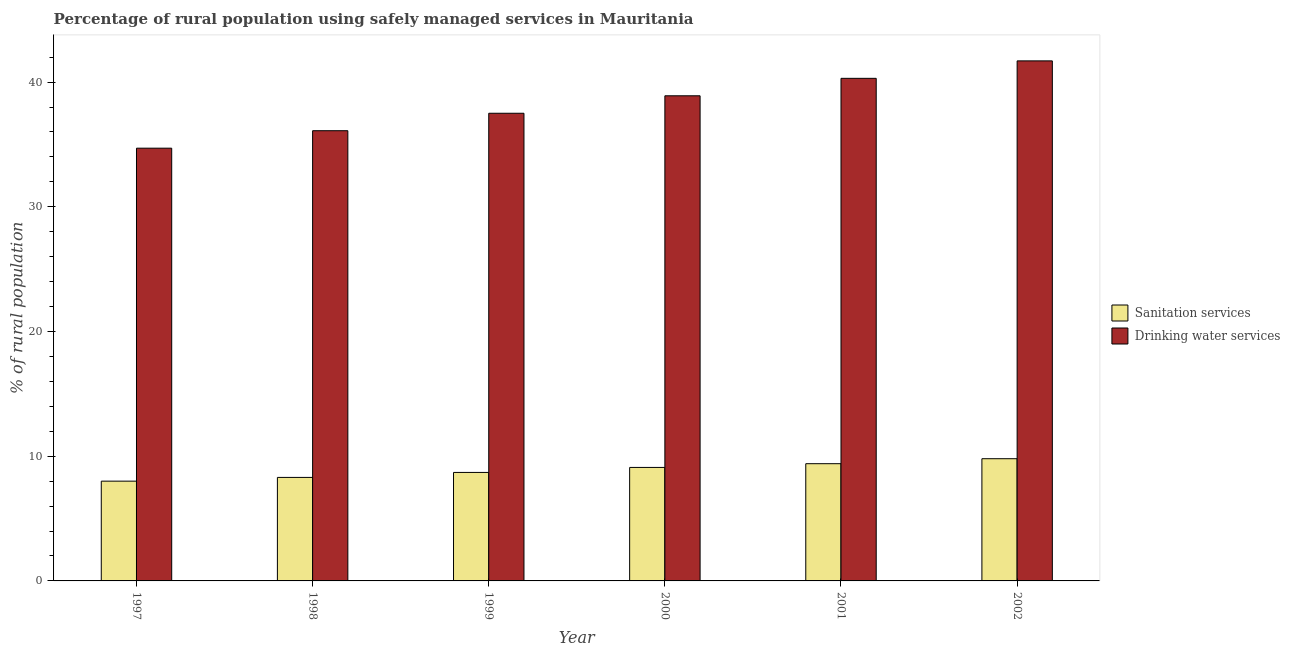How many different coloured bars are there?
Provide a short and direct response. 2. Are the number of bars per tick equal to the number of legend labels?
Give a very brief answer. Yes. What is the label of the 5th group of bars from the left?
Make the answer very short. 2001. Across all years, what is the maximum percentage of rural population who used drinking water services?
Provide a short and direct response. 41.7. Across all years, what is the minimum percentage of rural population who used sanitation services?
Offer a terse response. 8. In which year was the percentage of rural population who used sanitation services minimum?
Your answer should be compact. 1997. What is the total percentage of rural population who used drinking water services in the graph?
Your answer should be very brief. 229.2. What is the difference between the percentage of rural population who used sanitation services in 1998 and that in 1999?
Make the answer very short. -0.4. What is the difference between the percentage of rural population who used sanitation services in 2000 and the percentage of rural population who used drinking water services in 1999?
Offer a terse response. 0.4. What is the average percentage of rural population who used drinking water services per year?
Your answer should be compact. 38.2. In how many years, is the percentage of rural population who used sanitation services greater than 12 %?
Make the answer very short. 0. What is the ratio of the percentage of rural population who used drinking water services in 1998 to that in 2002?
Provide a short and direct response. 0.87. Is the percentage of rural population who used drinking water services in 1997 less than that in 1998?
Provide a short and direct response. Yes. What is the difference between the highest and the second highest percentage of rural population who used drinking water services?
Offer a terse response. 1.4. What is the difference between the highest and the lowest percentage of rural population who used drinking water services?
Ensure brevity in your answer.  7. What does the 2nd bar from the left in 1998 represents?
Your response must be concise. Drinking water services. What does the 1st bar from the right in 1999 represents?
Your response must be concise. Drinking water services. How many bars are there?
Ensure brevity in your answer.  12. Are all the bars in the graph horizontal?
Offer a very short reply. No. What is the difference between two consecutive major ticks on the Y-axis?
Ensure brevity in your answer.  10. Does the graph contain any zero values?
Give a very brief answer. No. What is the title of the graph?
Provide a short and direct response. Percentage of rural population using safely managed services in Mauritania. What is the label or title of the X-axis?
Ensure brevity in your answer.  Year. What is the label or title of the Y-axis?
Ensure brevity in your answer.  % of rural population. What is the % of rural population of Sanitation services in 1997?
Ensure brevity in your answer.  8. What is the % of rural population of Drinking water services in 1997?
Offer a very short reply. 34.7. What is the % of rural population of Drinking water services in 1998?
Keep it short and to the point. 36.1. What is the % of rural population in Sanitation services in 1999?
Provide a succinct answer. 8.7. What is the % of rural population in Drinking water services in 1999?
Provide a short and direct response. 37.5. What is the % of rural population in Sanitation services in 2000?
Your answer should be compact. 9.1. What is the % of rural population of Drinking water services in 2000?
Your answer should be very brief. 38.9. What is the % of rural population in Drinking water services in 2001?
Your answer should be compact. 40.3. What is the % of rural population of Sanitation services in 2002?
Your answer should be compact. 9.8. What is the % of rural population of Drinking water services in 2002?
Offer a terse response. 41.7. Across all years, what is the maximum % of rural population in Sanitation services?
Your answer should be compact. 9.8. Across all years, what is the maximum % of rural population in Drinking water services?
Offer a terse response. 41.7. Across all years, what is the minimum % of rural population in Drinking water services?
Provide a succinct answer. 34.7. What is the total % of rural population in Sanitation services in the graph?
Ensure brevity in your answer.  53.3. What is the total % of rural population of Drinking water services in the graph?
Your answer should be compact. 229.2. What is the difference between the % of rural population of Drinking water services in 1997 and that in 1998?
Keep it short and to the point. -1.4. What is the difference between the % of rural population in Sanitation services in 1997 and that in 1999?
Your response must be concise. -0.7. What is the difference between the % of rural population in Drinking water services in 1997 and that in 1999?
Offer a very short reply. -2.8. What is the difference between the % of rural population in Sanitation services in 1997 and that in 2001?
Provide a short and direct response. -1.4. What is the difference between the % of rural population of Sanitation services in 1997 and that in 2002?
Offer a very short reply. -1.8. What is the difference between the % of rural population in Drinking water services in 1997 and that in 2002?
Your response must be concise. -7. What is the difference between the % of rural population of Drinking water services in 1998 and that in 1999?
Provide a succinct answer. -1.4. What is the difference between the % of rural population of Sanitation services in 1998 and that in 2001?
Make the answer very short. -1.1. What is the difference between the % of rural population of Drinking water services in 1998 and that in 2001?
Make the answer very short. -4.2. What is the difference between the % of rural population of Sanitation services in 1999 and that in 2000?
Your answer should be very brief. -0.4. What is the difference between the % of rural population in Drinking water services in 1999 and that in 2000?
Your response must be concise. -1.4. What is the difference between the % of rural population in Sanitation services in 1999 and that in 2001?
Ensure brevity in your answer.  -0.7. What is the difference between the % of rural population in Drinking water services in 1999 and that in 2002?
Give a very brief answer. -4.2. What is the difference between the % of rural population of Sanitation services in 2000 and that in 2001?
Keep it short and to the point. -0.3. What is the difference between the % of rural population in Sanitation services in 2000 and that in 2002?
Keep it short and to the point. -0.7. What is the difference between the % of rural population in Drinking water services in 2000 and that in 2002?
Provide a succinct answer. -2.8. What is the difference between the % of rural population in Sanitation services in 2001 and that in 2002?
Give a very brief answer. -0.4. What is the difference between the % of rural population of Drinking water services in 2001 and that in 2002?
Ensure brevity in your answer.  -1.4. What is the difference between the % of rural population of Sanitation services in 1997 and the % of rural population of Drinking water services in 1998?
Offer a terse response. -28.1. What is the difference between the % of rural population of Sanitation services in 1997 and the % of rural population of Drinking water services in 1999?
Offer a terse response. -29.5. What is the difference between the % of rural population of Sanitation services in 1997 and the % of rural population of Drinking water services in 2000?
Offer a terse response. -30.9. What is the difference between the % of rural population in Sanitation services in 1997 and the % of rural population in Drinking water services in 2001?
Offer a very short reply. -32.3. What is the difference between the % of rural population in Sanitation services in 1997 and the % of rural population in Drinking water services in 2002?
Make the answer very short. -33.7. What is the difference between the % of rural population in Sanitation services in 1998 and the % of rural population in Drinking water services in 1999?
Your answer should be compact. -29.2. What is the difference between the % of rural population in Sanitation services in 1998 and the % of rural population in Drinking water services in 2000?
Your response must be concise. -30.6. What is the difference between the % of rural population of Sanitation services in 1998 and the % of rural population of Drinking water services in 2001?
Your response must be concise. -32. What is the difference between the % of rural population in Sanitation services in 1998 and the % of rural population in Drinking water services in 2002?
Make the answer very short. -33.4. What is the difference between the % of rural population in Sanitation services in 1999 and the % of rural population in Drinking water services in 2000?
Offer a terse response. -30.2. What is the difference between the % of rural population of Sanitation services in 1999 and the % of rural population of Drinking water services in 2001?
Your answer should be very brief. -31.6. What is the difference between the % of rural population of Sanitation services in 1999 and the % of rural population of Drinking water services in 2002?
Ensure brevity in your answer.  -33. What is the difference between the % of rural population of Sanitation services in 2000 and the % of rural population of Drinking water services in 2001?
Your answer should be compact. -31.2. What is the difference between the % of rural population in Sanitation services in 2000 and the % of rural population in Drinking water services in 2002?
Offer a terse response. -32.6. What is the difference between the % of rural population in Sanitation services in 2001 and the % of rural population in Drinking water services in 2002?
Give a very brief answer. -32.3. What is the average % of rural population in Sanitation services per year?
Keep it short and to the point. 8.88. What is the average % of rural population in Drinking water services per year?
Your response must be concise. 38.2. In the year 1997, what is the difference between the % of rural population of Sanitation services and % of rural population of Drinking water services?
Provide a short and direct response. -26.7. In the year 1998, what is the difference between the % of rural population in Sanitation services and % of rural population in Drinking water services?
Your response must be concise. -27.8. In the year 1999, what is the difference between the % of rural population in Sanitation services and % of rural population in Drinking water services?
Your answer should be compact. -28.8. In the year 2000, what is the difference between the % of rural population in Sanitation services and % of rural population in Drinking water services?
Ensure brevity in your answer.  -29.8. In the year 2001, what is the difference between the % of rural population in Sanitation services and % of rural population in Drinking water services?
Provide a short and direct response. -30.9. In the year 2002, what is the difference between the % of rural population of Sanitation services and % of rural population of Drinking water services?
Offer a terse response. -31.9. What is the ratio of the % of rural population of Sanitation services in 1997 to that in 1998?
Make the answer very short. 0.96. What is the ratio of the % of rural population in Drinking water services in 1997 to that in 1998?
Your response must be concise. 0.96. What is the ratio of the % of rural population in Sanitation services in 1997 to that in 1999?
Your response must be concise. 0.92. What is the ratio of the % of rural population of Drinking water services in 1997 to that in 1999?
Provide a succinct answer. 0.93. What is the ratio of the % of rural population in Sanitation services in 1997 to that in 2000?
Offer a very short reply. 0.88. What is the ratio of the % of rural population in Drinking water services in 1997 to that in 2000?
Provide a short and direct response. 0.89. What is the ratio of the % of rural population in Sanitation services in 1997 to that in 2001?
Your answer should be very brief. 0.85. What is the ratio of the % of rural population of Drinking water services in 1997 to that in 2001?
Offer a very short reply. 0.86. What is the ratio of the % of rural population of Sanitation services in 1997 to that in 2002?
Keep it short and to the point. 0.82. What is the ratio of the % of rural population of Drinking water services in 1997 to that in 2002?
Your answer should be compact. 0.83. What is the ratio of the % of rural population of Sanitation services in 1998 to that in 1999?
Your answer should be compact. 0.95. What is the ratio of the % of rural population of Drinking water services in 1998 to that in 1999?
Provide a short and direct response. 0.96. What is the ratio of the % of rural population of Sanitation services in 1998 to that in 2000?
Your answer should be compact. 0.91. What is the ratio of the % of rural population in Drinking water services in 1998 to that in 2000?
Ensure brevity in your answer.  0.93. What is the ratio of the % of rural population of Sanitation services in 1998 to that in 2001?
Your answer should be compact. 0.88. What is the ratio of the % of rural population of Drinking water services in 1998 to that in 2001?
Give a very brief answer. 0.9. What is the ratio of the % of rural population of Sanitation services in 1998 to that in 2002?
Offer a very short reply. 0.85. What is the ratio of the % of rural population of Drinking water services in 1998 to that in 2002?
Your answer should be very brief. 0.87. What is the ratio of the % of rural population in Sanitation services in 1999 to that in 2000?
Provide a succinct answer. 0.96. What is the ratio of the % of rural population of Drinking water services in 1999 to that in 2000?
Provide a succinct answer. 0.96. What is the ratio of the % of rural population of Sanitation services in 1999 to that in 2001?
Provide a short and direct response. 0.93. What is the ratio of the % of rural population of Drinking water services in 1999 to that in 2001?
Ensure brevity in your answer.  0.93. What is the ratio of the % of rural population in Sanitation services in 1999 to that in 2002?
Ensure brevity in your answer.  0.89. What is the ratio of the % of rural population of Drinking water services in 1999 to that in 2002?
Ensure brevity in your answer.  0.9. What is the ratio of the % of rural population in Sanitation services in 2000 to that in 2001?
Provide a short and direct response. 0.97. What is the ratio of the % of rural population in Drinking water services in 2000 to that in 2001?
Provide a succinct answer. 0.97. What is the ratio of the % of rural population in Sanitation services in 2000 to that in 2002?
Keep it short and to the point. 0.93. What is the ratio of the % of rural population in Drinking water services in 2000 to that in 2002?
Ensure brevity in your answer.  0.93. What is the ratio of the % of rural population of Sanitation services in 2001 to that in 2002?
Your response must be concise. 0.96. What is the ratio of the % of rural population in Drinking water services in 2001 to that in 2002?
Your answer should be compact. 0.97. 